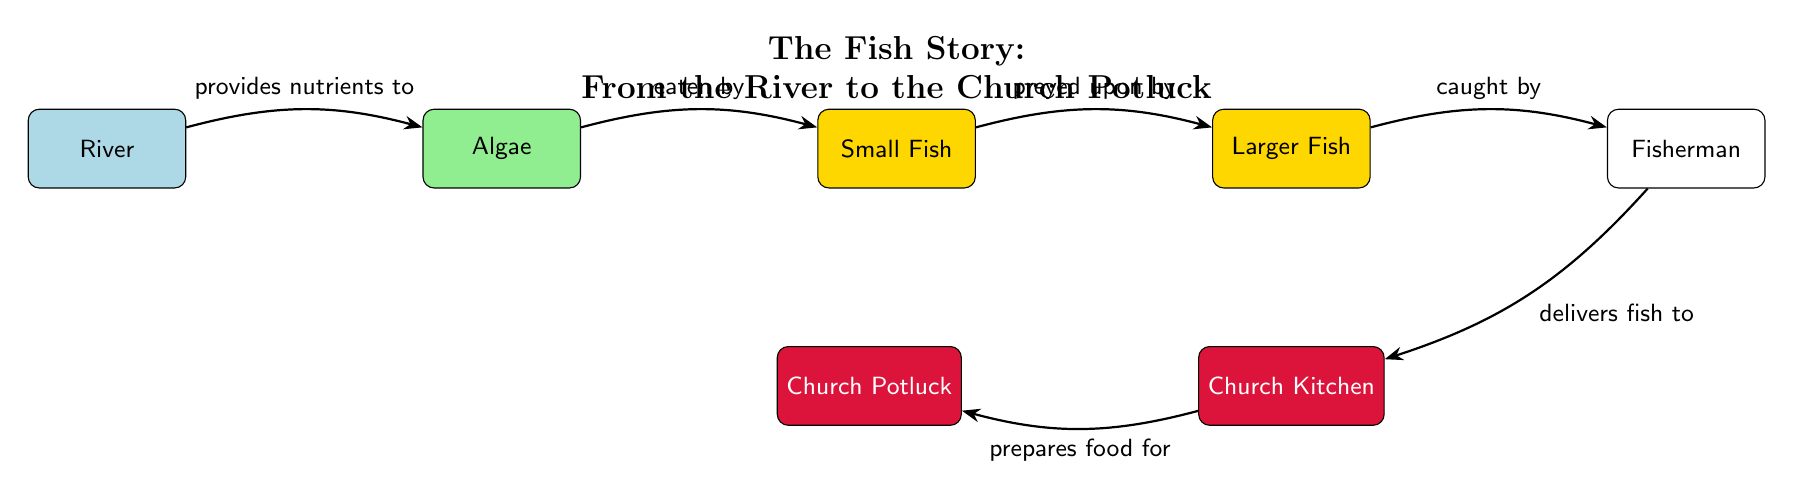What is the first element in the food chain? The diagram begins with the "River" as the first element in the food chain, which is shown on the far left.
Answer: River How many types of fish are present in the food chain? There are two types of fish represented in the food chain: "Small Fish" and "Larger Fish." They are listed consecutively after the algae.
Answer: 2 What does the river provide to the algae? The arrow from the "River" to the "Algae" states that the river "provides nutrients to" the algae.
Answer: nutrients Who catches the larger fish? The arrow pointing from "Larger Fish" to "Fisherman" indicates that the fisherman "catches" the larger fish.
Answer: Fisherman How does the fish end up at the church potluck? The fish moves from being "caught by" the fisherman to being "delivered" to the church kitchen, which then "prepares food for" the potluck. This indicates a series of connections leading to the final potluck event.
Answer: Church Potluck What role does the church kitchen play in the food chain? The church kitchen is indicated as the node that "prepares food for" the church potluck, showing its function in the overall food flow.
Answer: prepares food What does the larger fish get eaten by? The diagram shows that "Larger Fish" is preyed upon by the "Fisherman," who catches them. Therefore, the larger fish is ultimately caught.
Answer: Fisherman Identify the nutrients source in this food chain. The "River" is explicitly stated as providing nutrients to "Algae," making it the source of nutrients in this food chain.
Answer: River What is the last entity the food chain connects to? The last node in the food chain is "Church Potluck," which receives food prepared by the church kitchen. It is the final destination in the flow.
Answer: Church Potluck 